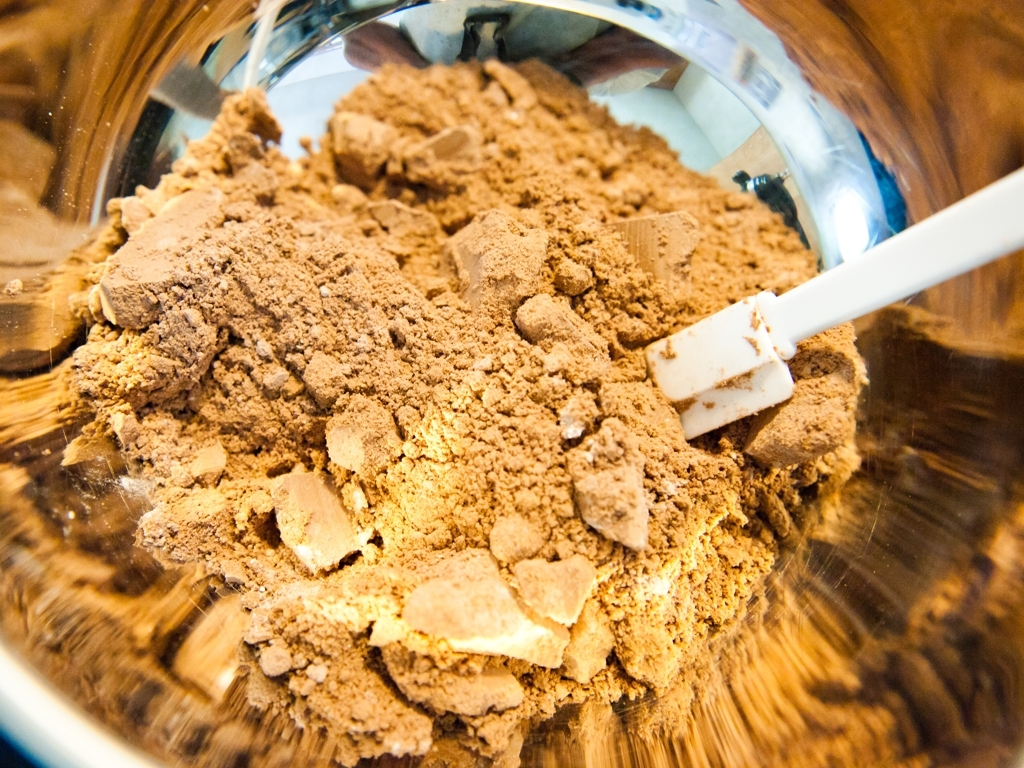Could you tell me more about the container holding the powder? Certainly! The container holding the powder seems to be made of glass, judging by the reflection and refraction of light visible on its surface. The curved sides suggest it could be a mixing bowl, which is often used in food preparation and cooking processes. 